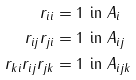Convert formula to latex. <formula><loc_0><loc_0><loc_500><loc_500>r _ { i i } & = 1 \text { in } A _ { i } \\ r _ { i j } r _ { j i } & = 1 \text { in } A _ { i j } \\ r _ { k i } r _ { i j } r _ { j k } & = 1 \text { in } A _ { i j k }</formula> 